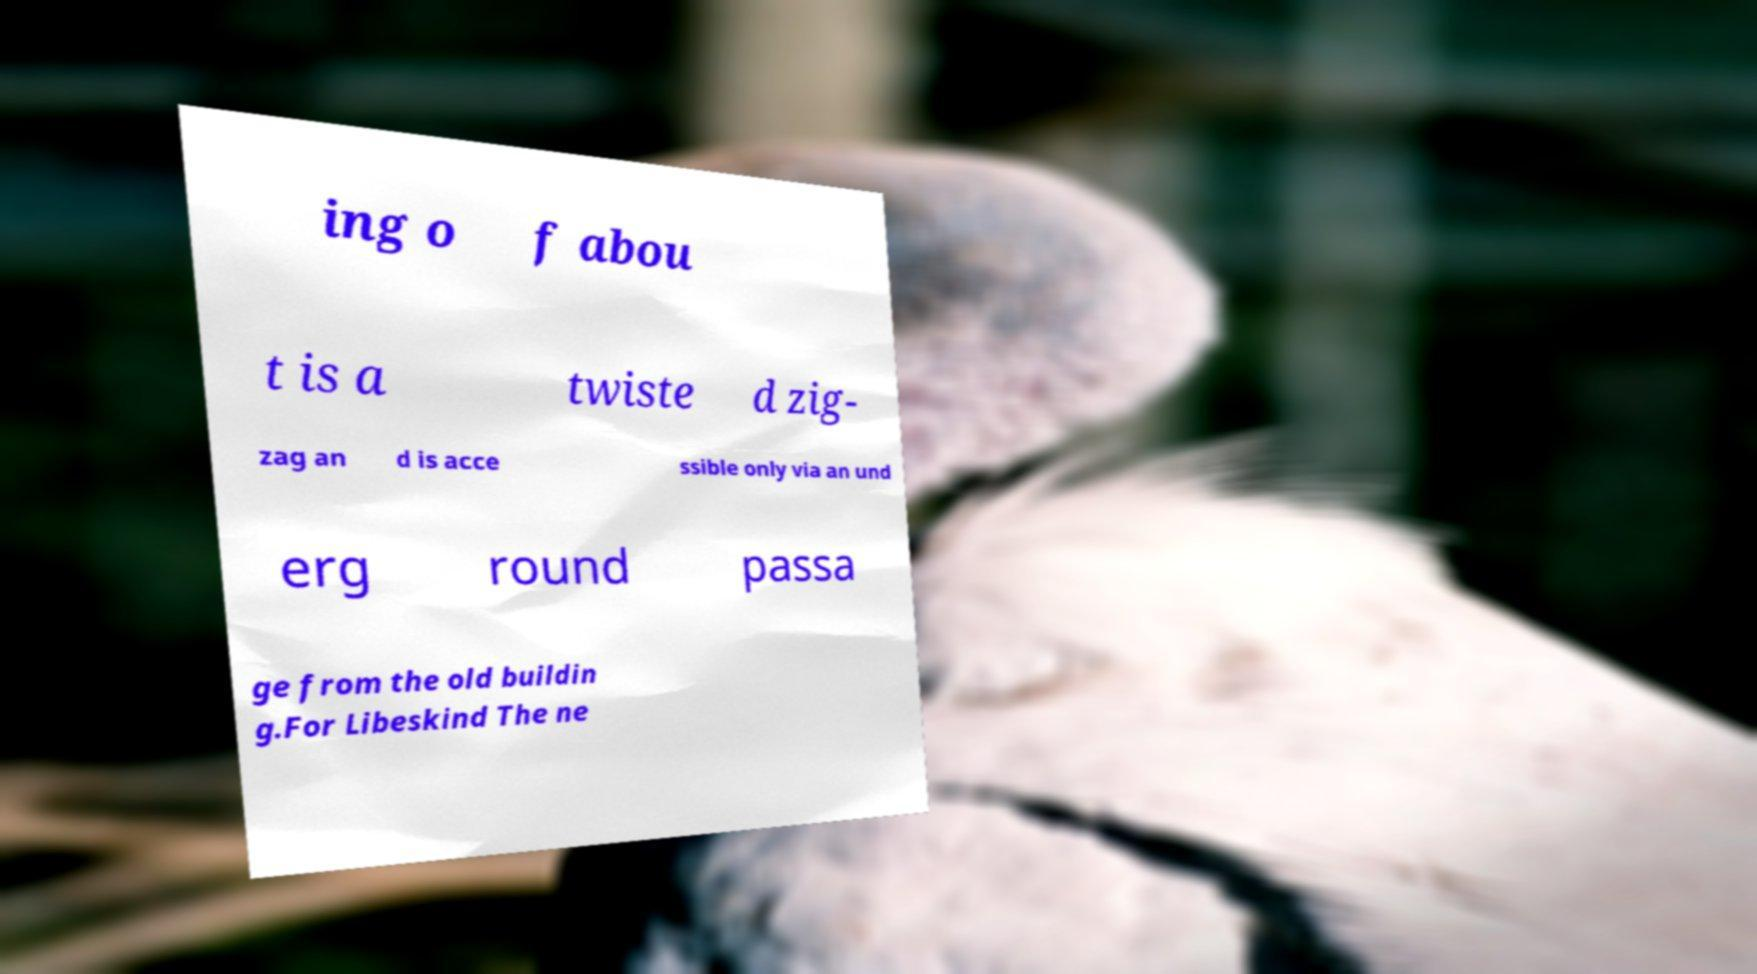Could you extract and type out the text from this image? ing o f abou t is a twiste d zig- zag an d is acce ssible only via an und erg round passa ge from the old buildin g.For Libeskind The ne 